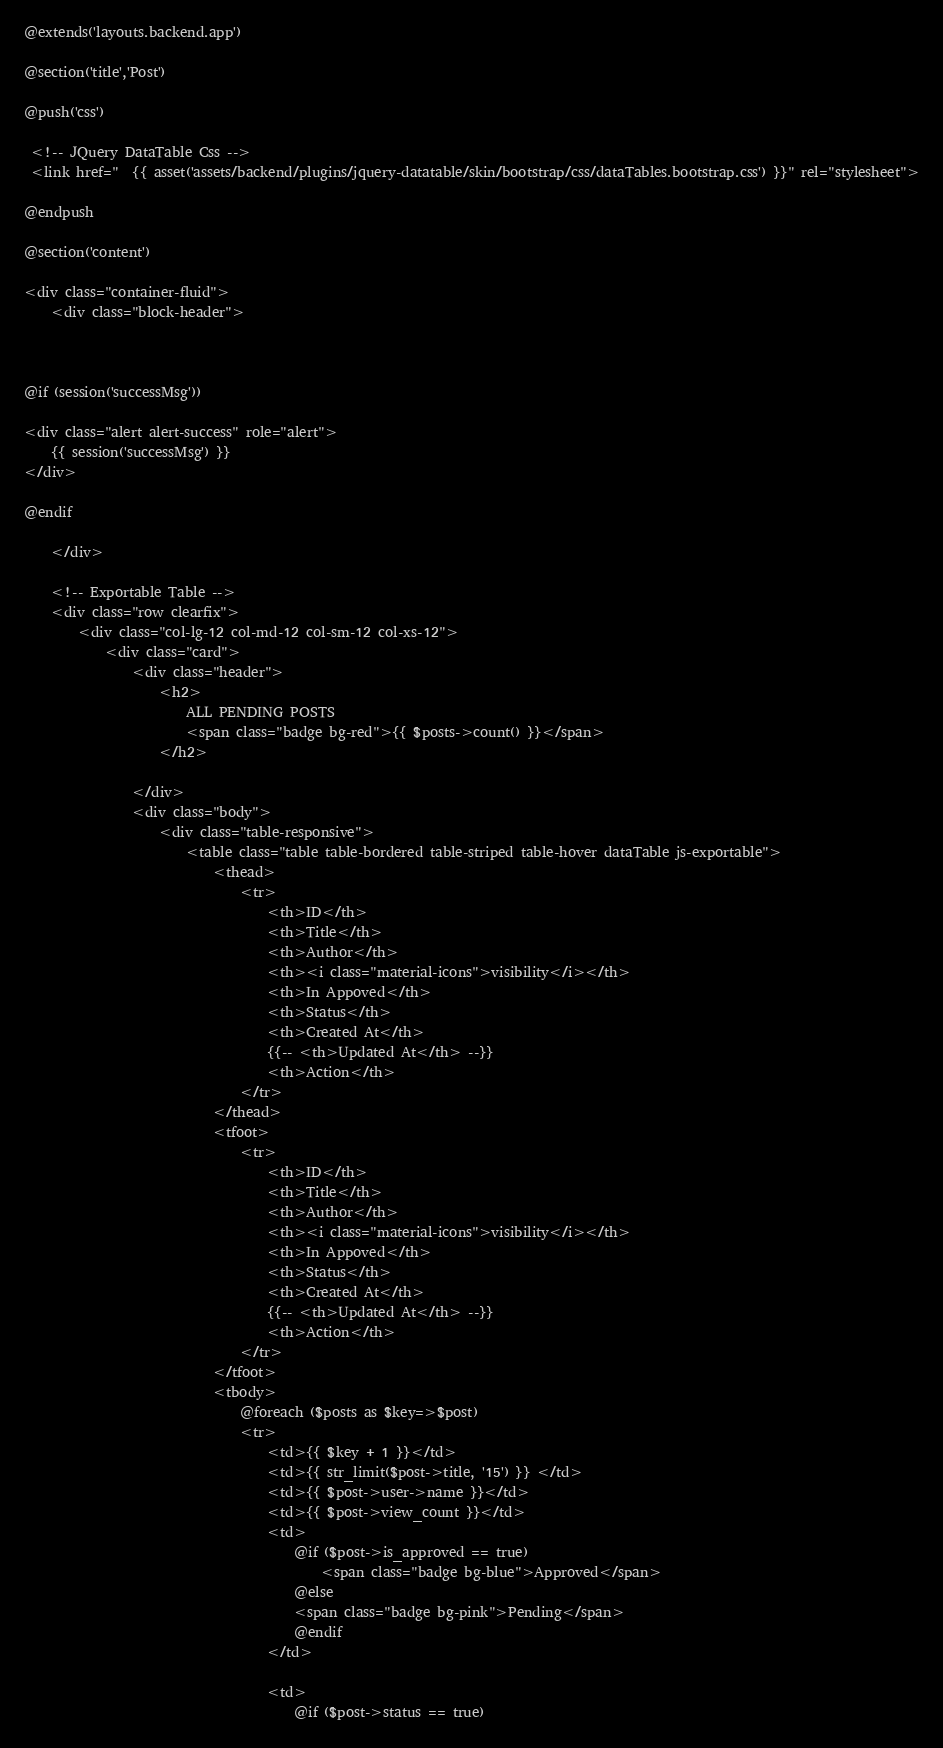Convert code to text. <code><loc_0><loc_0><loc_500><loc_500><_PHP_>@extends('layouts.backend.app')

@section('title','Post')

@push('css')

 <!-- JQuery DataTable Css -->
 <link href="  {{ asset('assets/backend/plugins/jquery-datatable/skin/bootstrap/css/dataTables.bootstrap.css') }}" rel="stylesheet">

@endpush

@section('content')

<div class="container-fluid">
    <div class="block-header">



@if (session('successMsg'))

<div class="alert alert-success" role="alert">
    {{ session('successMsg') }}
</div>

@endif

    </div>

    <!-- Exportable Table -->
    <div class="row clearfix">
        <div class="col-lg-12 col-md-12 col-sm-12 col-xs-12">
            <div class="card">
                <div class="header">
                    <h2>
                        ALL PENDING POSTS
                        <span class="badge bg-red">{{ $posts->count() }}</span>
                    </h2>

                </div>
                <div class="body">
                    <div class="table-responsive">
                        <table class="table table-bordered table-striped table-hover dataTable js-exportable">
                            <thead>
                                <tr>
                                    <th>ID</th>
                                    <th>Title</th>
                                    <th>Author</th>
                                    <th><i class="material-icons">visibility</i></th>
                                    <th>In Appoved</th>
                                    <th>Status</th>
                                    <th>Created At</th>
                                    {{-- <th>Updated At</th> --}}
                                    <th>Action</th>
                                </tr>
                            </thead>
                            <tfoot>
                                <tr>
                                    <th>ID</th>
                                    <th>Title</th>
                                    <th>Author</th>
                                    <th><i class="material-icons">visibility</i></th>
                                    <th>In Appoved</th>
                                    <th>Status</th>
                                    <th>Created At</th>
                                    {{-- <th>Updated At</th> --}}
                                    <th>Action</th>
                                </tr>
                            </tfoot>
                            <tbody>
                                @foreach ($posts as $key=>$post)
                                <tr>
                                    <td>{{ $key + 1 }}</td>
                                    <td>{{ str_limit($post->title, '15') }} </td>
                                    <td>{{ $post->user->name }}</td>
                                    <td>{{ $post->view_count }}</td>
                                    <td>
                                        @if ($post->is_approved == true)
                                            <span class="badge bg-blue">Approved</span>
                                        @else
                                        <span class="badge bg-pink">Pending</span>
                                        @endif
                                    </td>

                                    <td>
                                        @if ($post->status == true)</code> 